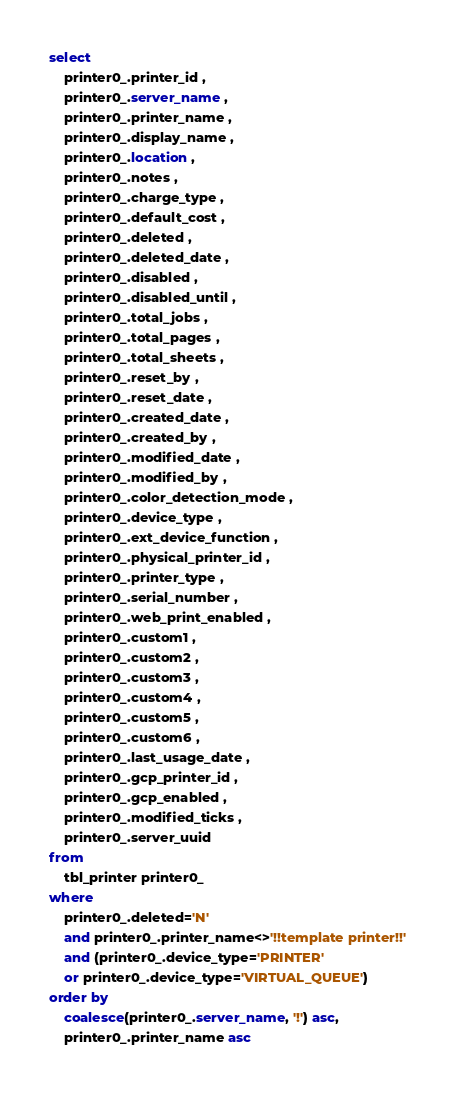<code> <loc_0><loc_0><loc_500><loc_500><_SQL_>select 
	printer0_.printer_id ,
	printer0_.server_name ,
	printer0_.printer_name ,
	printer0_.display_name ,
	printer0_.location ,
	printer0_.notes ,
	printer0_.charge_type ,
	printer0_.default_cost ,
	printer0_.deleted ,
	printer0_.deleted_date ,
	printer0_.disabled ,
	printer0_.disabled_until ,
	printer0_.total_jobs ,
	printer0_.total_pages ,
	printer0_.total_sheets ,
	printer0_.reset_by ,
	printer0_.reset_date ,
	printer0_.created_date ,
	printer0_.created_by ,
	printer0_.modified_date ,
	printer0_.modified_by ,
	printer0_.color_detection_mode ,
	printer0_.device_type ,
	printer0_.ext_device_function ,
	printer0_.physical_printer_id ,
	printer0_.printer_type ,
	printer0_.serial_number ,
	printer0_.web_print_enabled ,
	printer0_.custom1 ,
	printer0_.custom2 ,
	printer0_.custom3 ,
	printer0_.custom4 ,
	printer0_.custom5 ,
	printer0_.custom6 ,
	printer0_.last_usage_date ,
	printer0_.gcp_printer_id ,
	printer0_.gcp_enabled ,
	printer0_.modified_ticks ,
	printer0_.server_uuid
from 
	tbl_printer printer0_ 
where 
	printer0_.deleted='N' 
	and printer0_.printer_name<>'!!template printer!!'
	and (printer0_.device_type='PRINTER'
	or printer0_.device_type='VIRTUAL_QUEUE') 
order by 
	coalesce(printer0_.server_name, '!') asc,
	printer0_.printer_name asc </code> 